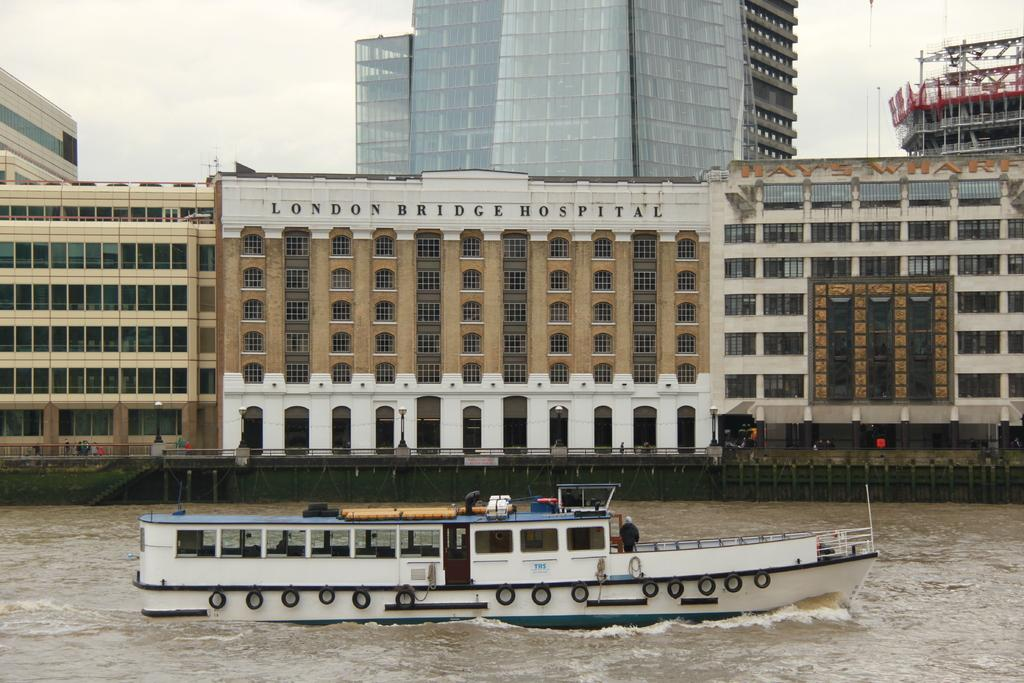<image>
Write a terse but informative summary of the picture. The boat sails past the London Bridge Hospital. 